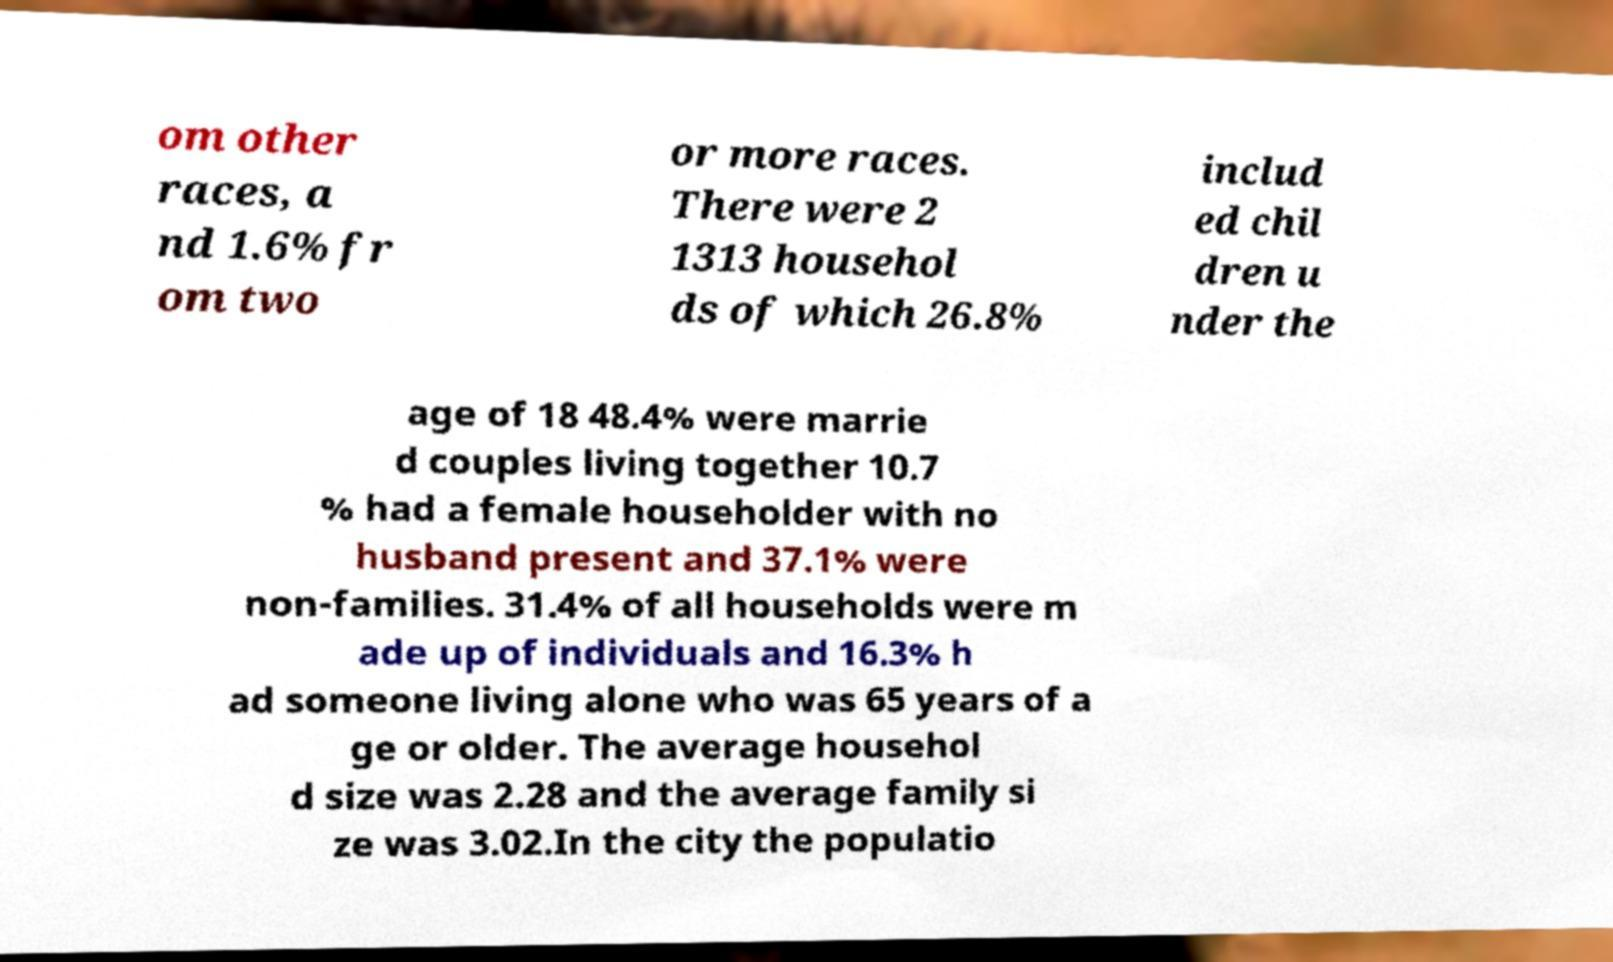Could you extract and type out the text from this image? om other races, a nd 1.6% fr om two or more races. There were 2 1313 househol ds of which 26.8% includ ed chil dren u nder the age of 18 48.4% were marrie d couples living together 10.7 % had a female householder with no husband present and 37.1% were non-families. 31.4% of all households were m ade up of individuals and 16.3% h ad someone living alone who was 65 years of a ge or older. The average househol d size was 2.28 and the average family si ze was 3.02.In the city the populatio 